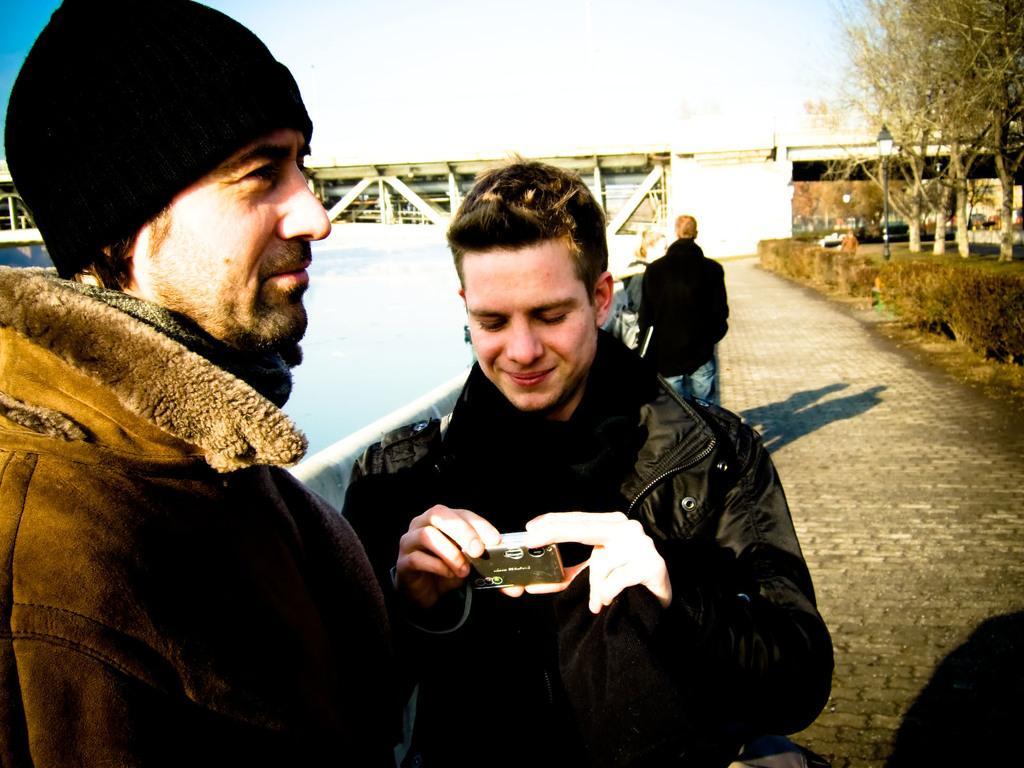How would you summarize this image in a sentence or two? Here we can see a 2 persons are standing on the floor, and holding some object in the hand, and at back here is the water, and here are the trees, and at above here is the sky. 